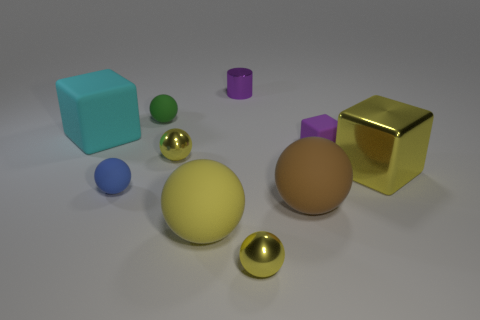Subtract all blue cylinders. How many yellow balls are left? 3 Subtract all brown rubber spheres. How many spheres are left? 5 Subtract all brown balls. How many balls are left? 5 Subtract 1 balls. How many balls are left? 5 Subtract all purple spheres. Subtract all cyan cubes. How many spheres are left? 6 Subtract all spheres. How many objects are left? 4 Add 4 green balls. How many green balls are left? 5 Add 2 tiny blue matte things. How many tiny blue matte things exist? 3 Subtract 0 purple spheres. How many objects are left? 10 Subtract all small blocks. Subtract all small yellow metal balls. How many objects are left? 7 